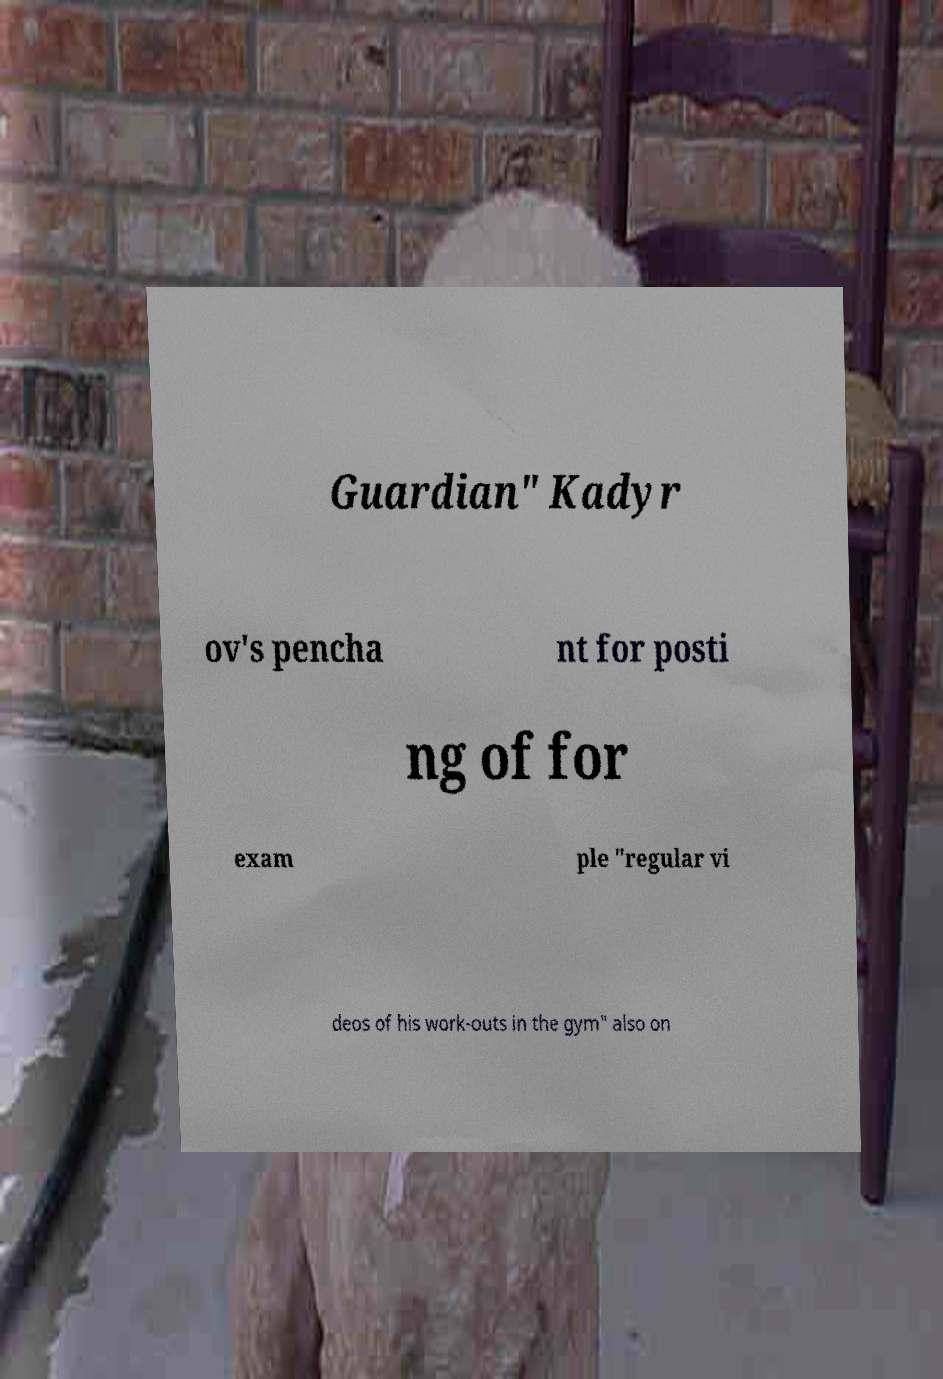For documentation purposes, I need the text within this image transcribed. Could you provide that? Guardian" Kadyr ov's pencha nt for posti ng of for exam ple "regular vi deos of his work-outs in the gym" also on 